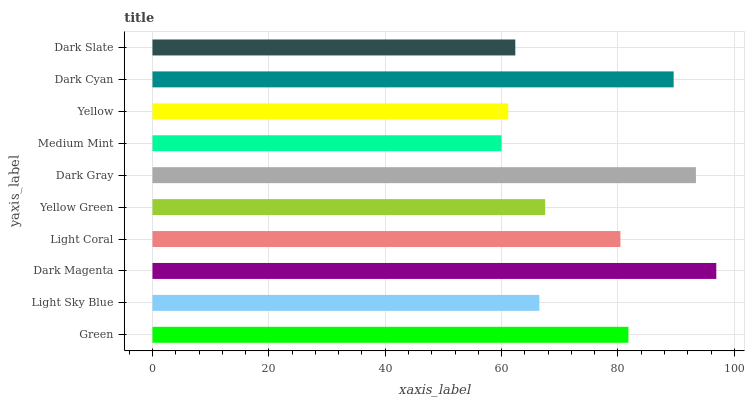Is Medium Mint the minimum?
Answer yes or no. Yes. Is Dark Magenta the maximum?
Answer yes or no. Yes. Is Light Sky Blue the minimum?
Answer yes or no. No. Is Light Sky Blue the maximum?
Answer yes or no. No. Is Green greater than Light Sky Blue?
Answer yes or no. Yes. Is Light Sky Blue less than Green?
Answer yes or no. Yes. Is Light Sky Blue greater than Green?
Answer yes or no. No. Is Green less than Light Sky Blue?
Answer yes or no. No. Is Light Coral the high median?
Answer yes or no. Yes. Is Yellow Green the low median?
Answer yes or no. Yes. Is Dark Magenta the high median?
Answer yes or no. No. Is Light Sky Blue the low median?
Answer yes or no. No. 